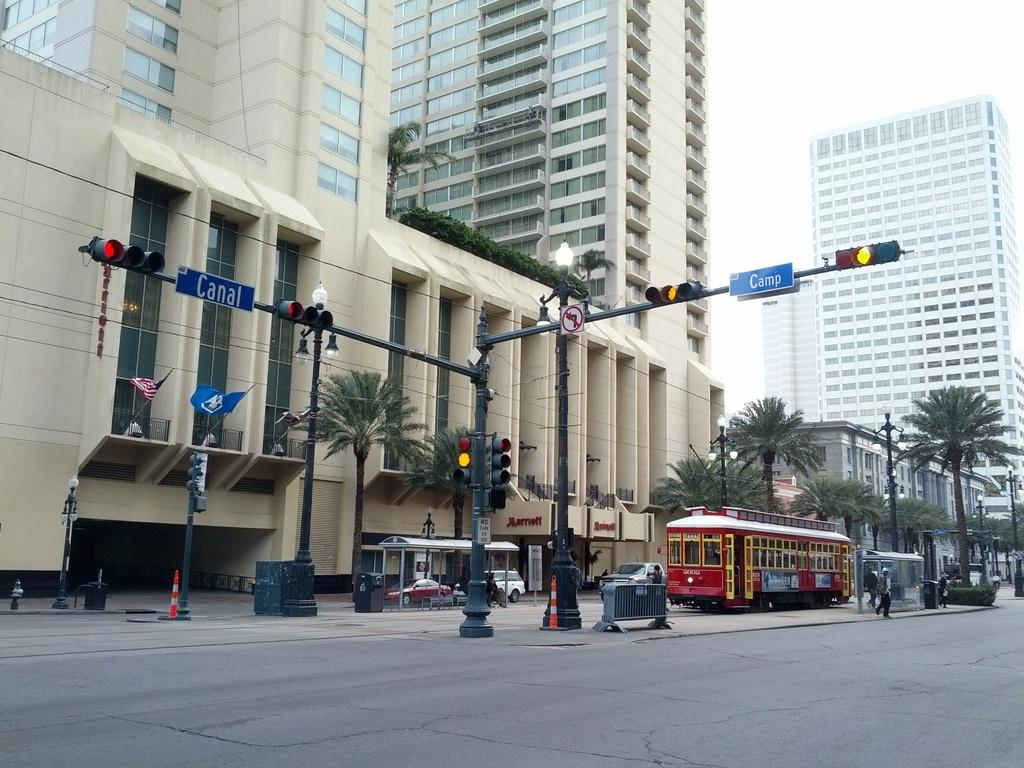Provide a one-sentence caption for the provided image. A red trolley at the intersection of Canal and Camp street. 